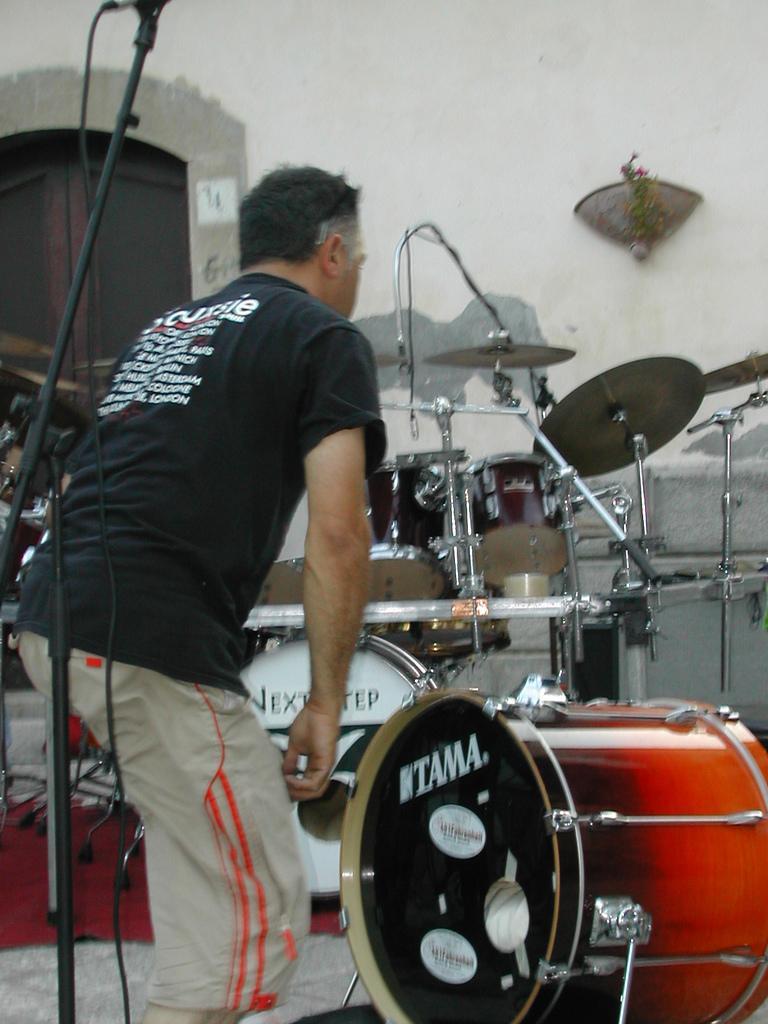Could you give a brief overview of what you see in this image? In this image we can see a person wearing a black t shirt is standing on the ground. In the background, we can see group of musical instruments and a microphone placed on a stand and a window. 